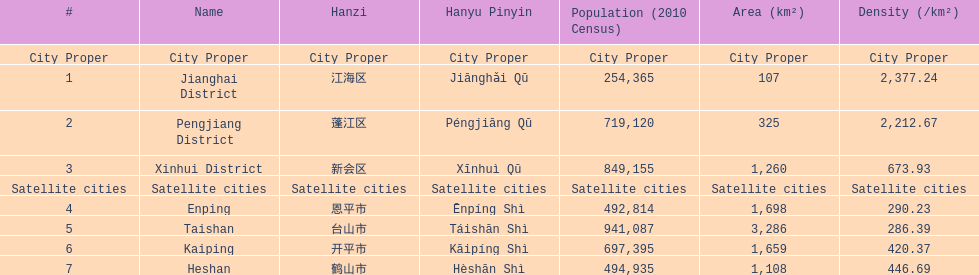Which area has the largest population? Taishan. 